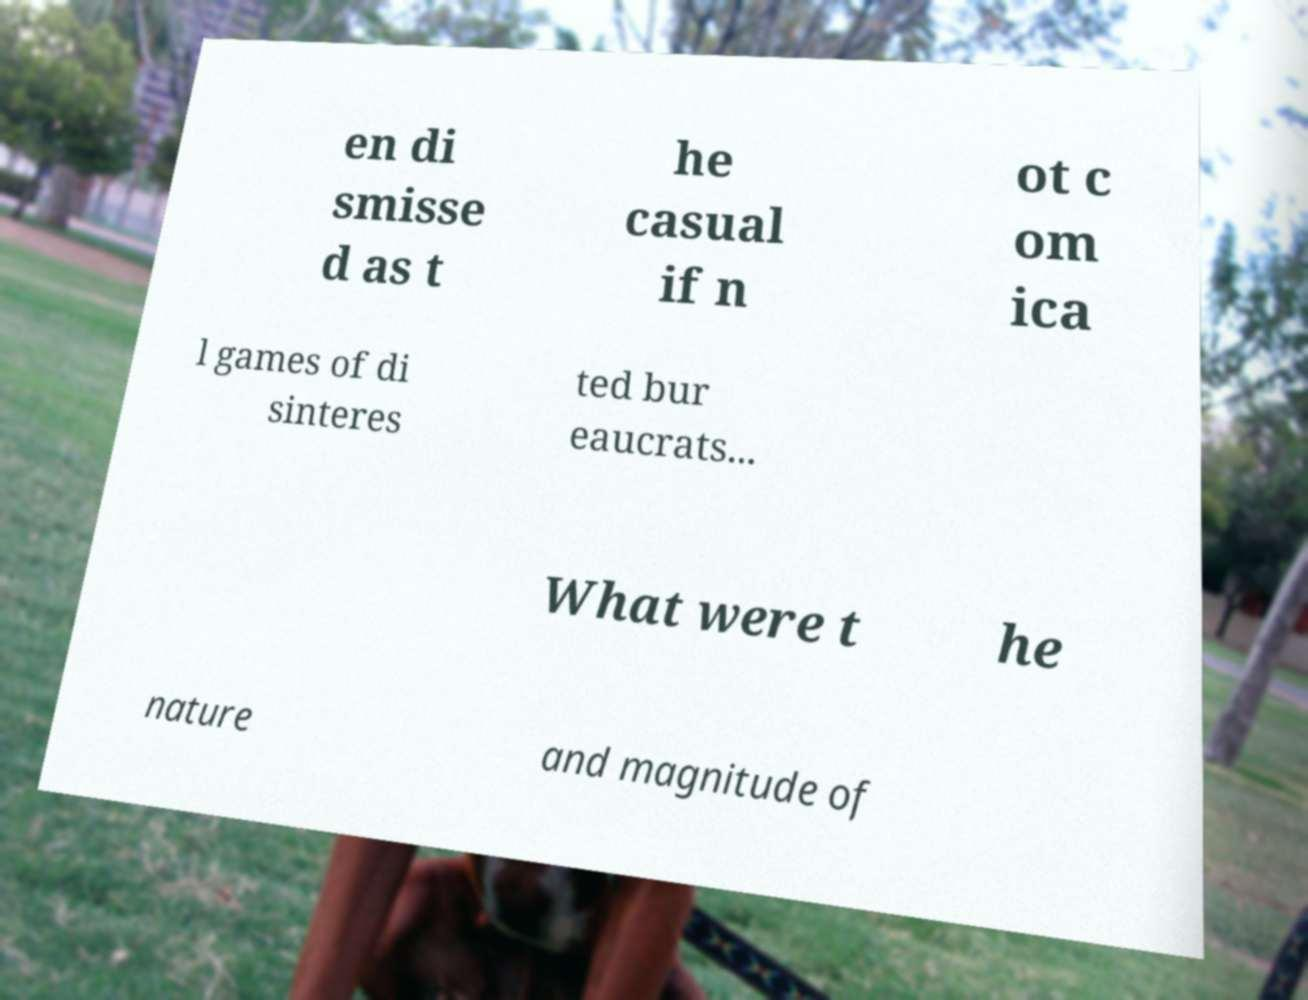What messages or text are displayed in this image? I need them in a readable, typed format. en di smisse d as t he casual if n ot c om ica l games of di sinteres ted bur eaucrats... What were t he nature and magnitude of 